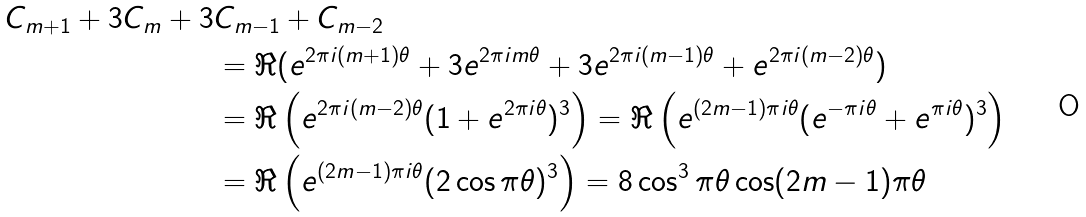<formula> <loc_0><loc_0><loc_500><loc_500>C _ { m + 1 } + 3 C _ { m } + 3 & C _ { m - 1 } + C _ { m - 2 } \\ & = \Re ( e ^ { 2 \pi i ( m + 1 ) \theta } + 3 e ^ { 2 \pi i m \theta } + 3 e ^ { 2 \pi i ( m - 1 ) \theta } + e ^ { 2 \pi i ( m - 2 ) \theta } ) \\ & = \Re \left ( e ^ { 2 \pi i ( m - 2 ) \theta } ( 1 + e ^ { 2 \pi i \theta } ) ^ { 3 } \right ) = \Re \left ( e ^ { ( 2 m - 1 ) \pi i \theta } ( e ^ { - \pi i \theta } + e ^ { \pi i \theta } ) ^ { 3 } \right ) \\ & = \Re \left ( e ^ { ( 2 m - 1 ) \pi i \theta } ( 2 \cos \pi \theta ) ^ { 3 } \right ) = 8 \cos ^ { 3 } \pi \theta \cos ( 2 m - 1 ) \pi \theta</formula> 